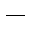Convert formula to latex. <formula><loc_0><loc_0><loc_500><loc_500>^ { - }</formula> 